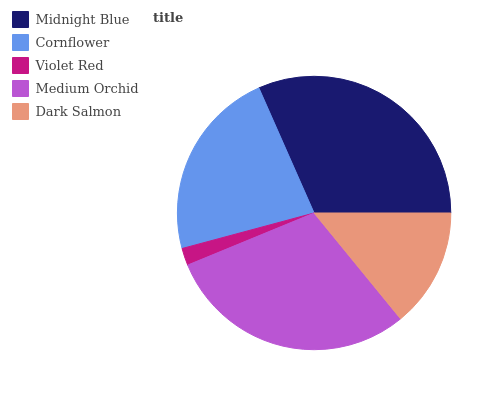Is Violet Red the minimum?
Answer yes or no. Yes. Is Midnight Blue the maximum?
Answer yes or no. Yes. Is Cornflower the minimum?
Answer yes or no. No. Is Cornflower the maximum?
Answer yes or no. No. Is Midnight Blue greater than Cornflower?
Answer yes or no. Yes. Is Cornflower less than Midnight Blue?
Answer yes or no. Yes. Is Cornflower greater than Midnight Blue?
Answer yes or no. No. Is Midnight Blue less than Cornflower?
Answer yes or no. No. Is Cornflower the high median?
Answer yes or no. Yes. Is Cornflower the low median?
Answer yes or no. Yes. Is Midnight Blue the high median?
Answer yes or no. No. Is Dark Salmon the low median?
Answer yes or no. No. 